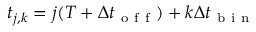Convert formula to latex. <formula><loc_0><loc_0><loc_500><loc_500>t _ { j , k } = j ( T + \Delta t _ { o f f } ) + k \Delta t _ { b i n }</formula> 